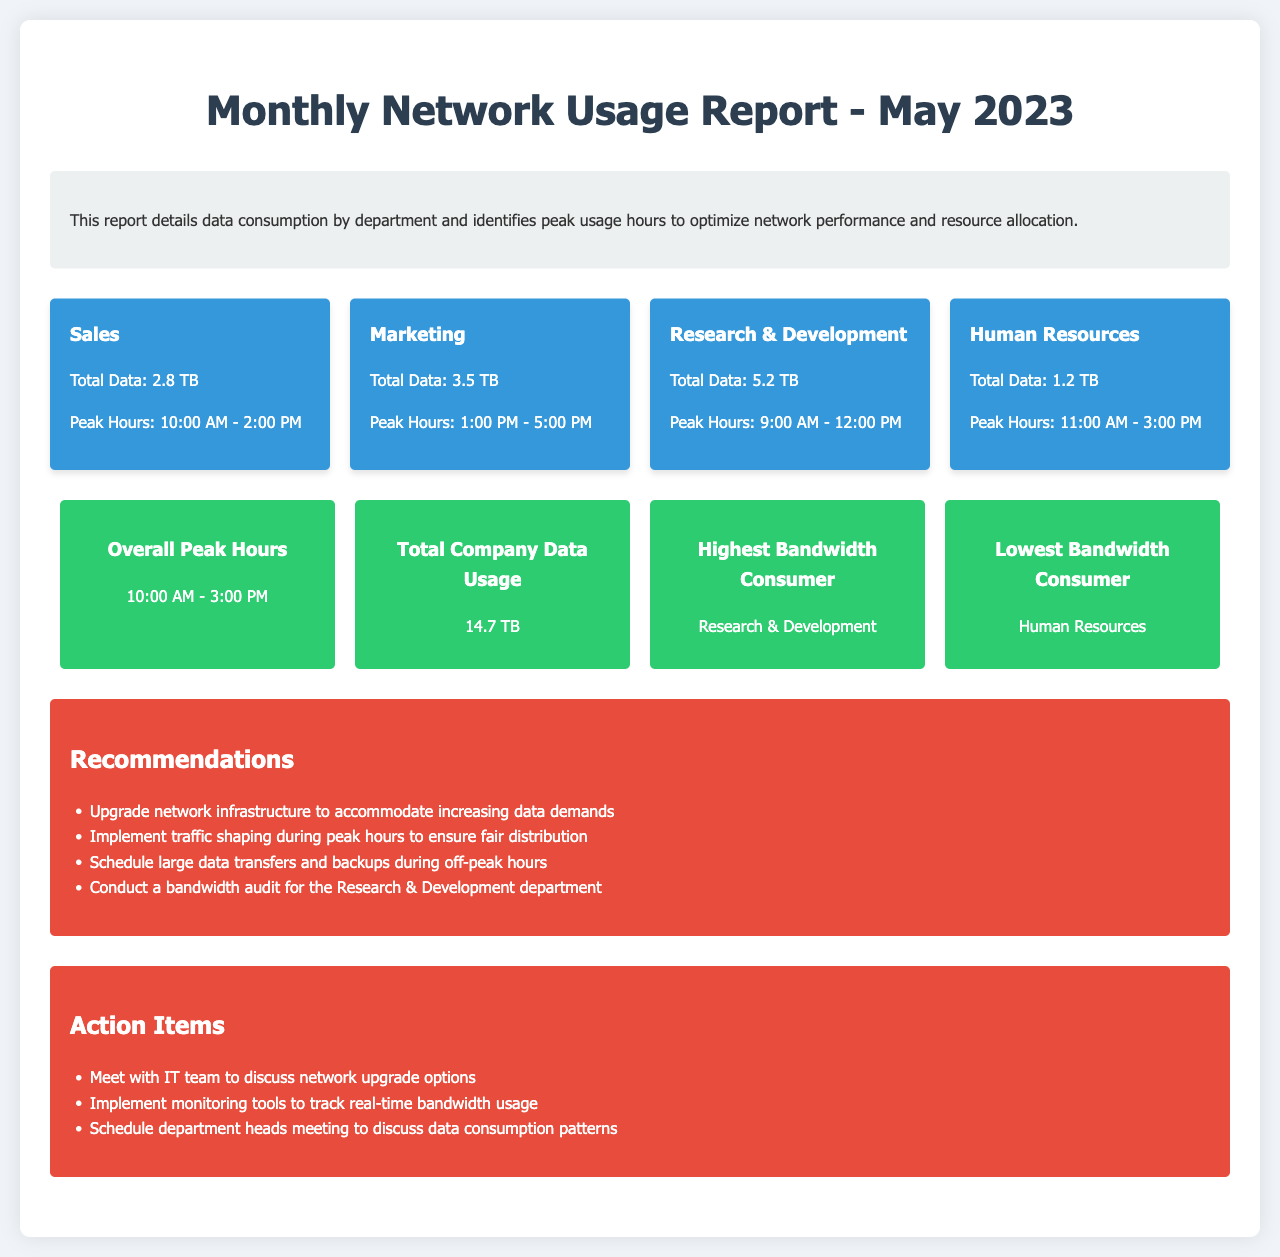What is the total data usage by the Sales department? The total data usage by the Sales department is stated in the document as 2.8 TB.
Answer: 2.8 TB What are the peak hours for Marketing? The peak hours for the Marketing department are provided as 1:00 PM - 5:00 PM in the document.
Answer: 1:00 PM - 5:00 PM Which department has the highest data consumption? The document states that Research & Development has the highest data consumption at 5.2 TB.
Answer: Research & Development What is the overall peak usage time across all departments? The overall peak usage time is aggregated from different departments, recorded as 10:00 AM - 3:00 PM.
Answer: 10:00 AM - 3:00 PM How much total data was consumed by the company? The total data usage reported for the company in May 2023 is 14.7 TB.
Answer: 14.7 TB What recommendation is given to accommodate increasing data demands? The document recommends upgrading network infrastructure to meet the increasing demands.
Answer: Upgrade network infrastructure What action item suggests monitoring bandwidth usage? The action item mentions implementing monitoring tools for tracking real-time bandwidth usage.
Answer: Implement monitoring tools How is the lowest bandwidth consumer identified in this report? The document specifies that Human Resources is identified as the lowest bandwidth consumer.
Answer: Human Resources What is suggested regarding large data transfers? The recommendation states to schedule large data transfers and backups during off-peak hours.
Answer: During off-peak hours 